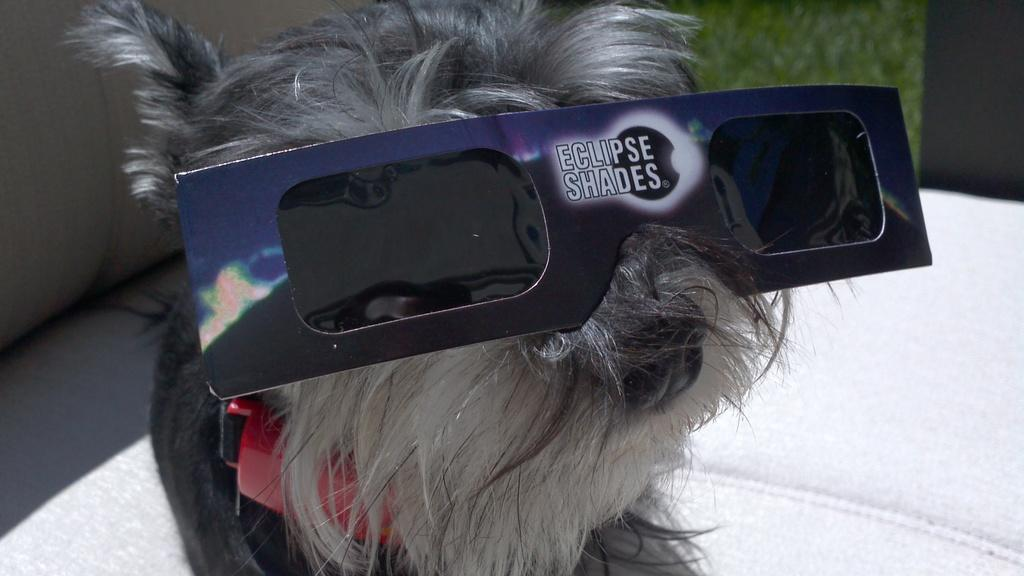What type of animal is present in the image? There is a dog in the image. What is the dog wearing in the image? The dog is wearing eclipse glasses in the image. What piece of furniture can be seen in the image? There is a chair in the image. What is the tax rate for the ship in the image? There is no ship present in the image, so it is not possible to determine the tax rate. 